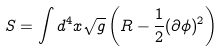Convert formula to latex. <formula><loc_0><loc_0><loc_500><loc_500>S = \int d ^ { 4 } x \sqrt { g } \left ( R - \frac { 1 } { 2 } ( \partial \phi ) ^ { 2 } \right )</formula> 